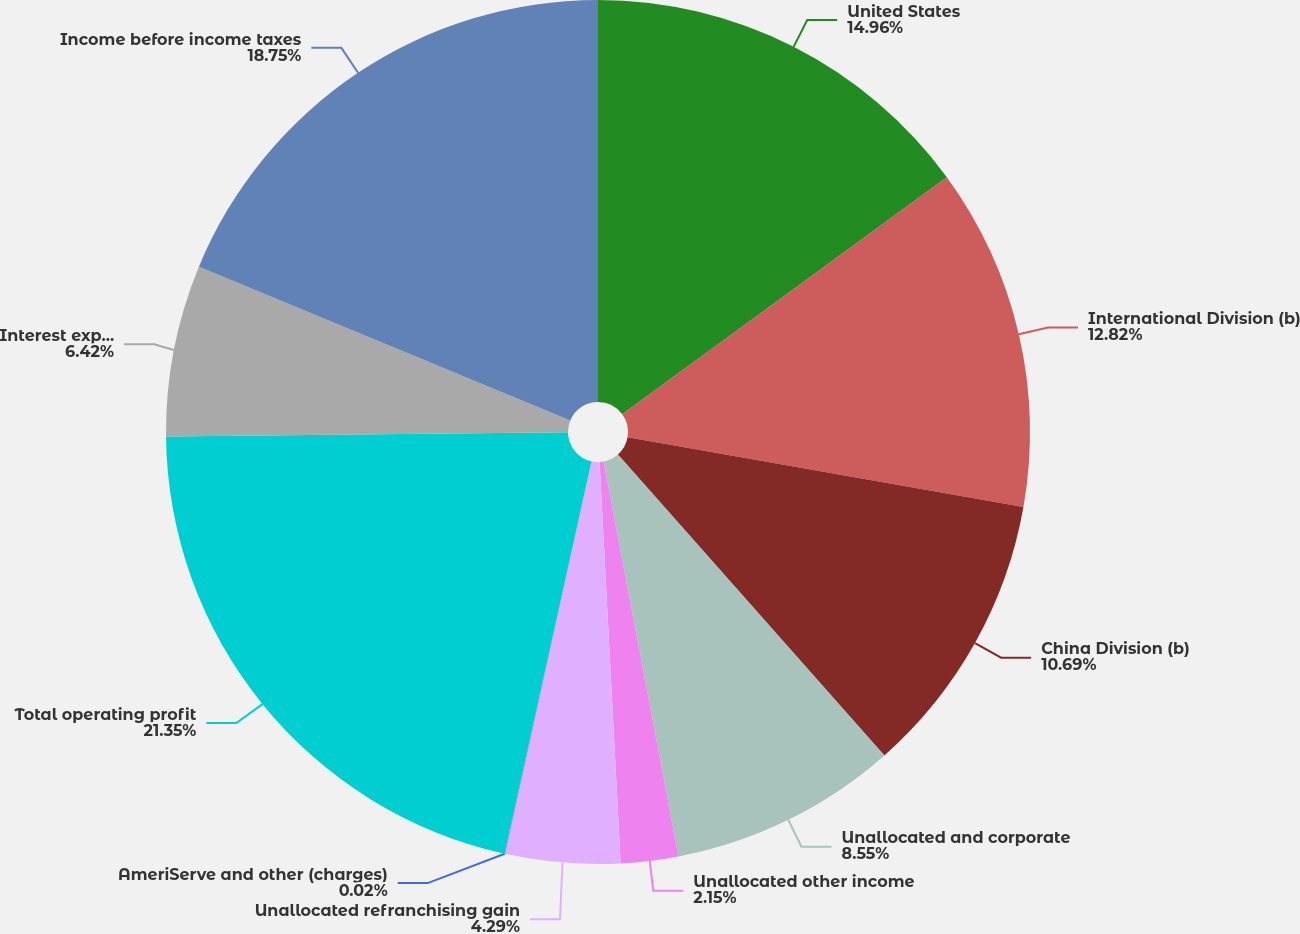<chart> <loc_0><loc_0><loc_500><loc_500><pie_chart><fcel>United States<fcel>International Division (b)<fcel>China Division (b)<fcel>Unallocated and corporate<fcel>Unallocated other income<fcel>Unallocated refranchising gain<fcel>AmeriServe and other (charges)<fcel>Total operating profit<fcel>Interest expense net<fcel>Income before income taxes<nl><fcel>14.96%<fcel>12.82%<fcel>10.69%<fcel>8.55%<fcel>2.15%<fcel>4.29%<fcel>0.02%<fcel>21.36%<fcel>6.42%<fcel>18.75%<nl></chart> 